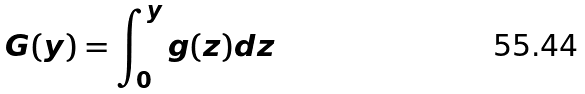Convert formula to latex. <formula><loc_0><loc_0><loc_500><loc_500>G ( y ) = \int _ { 0 } ^ { y } g ( z ) d z</formula> 